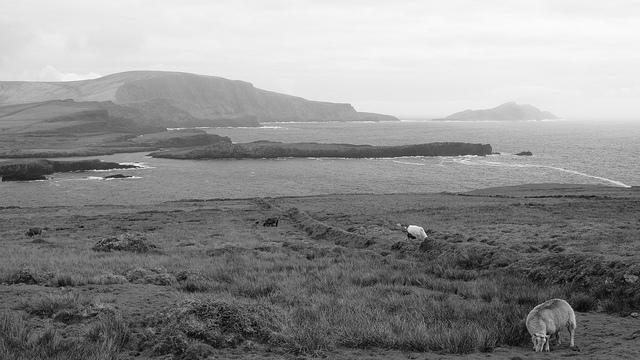What kind of an area is this?
Indicate the correct response by choosing from the four available options to answer the question.
Options: Metropolitan, coastal, desert, jungle. Coastal. 